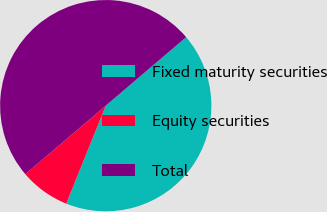Convert chart to OTSL. <chart><loc_0><loc_0><loc_500><loc_500><pie_chart><fcel>Fixed maturity securities<fcel>Equity securities<fcel>Total<nl><fcel>42.33%<fcel>7.67%<fcel>50.0%<nl></chart> 